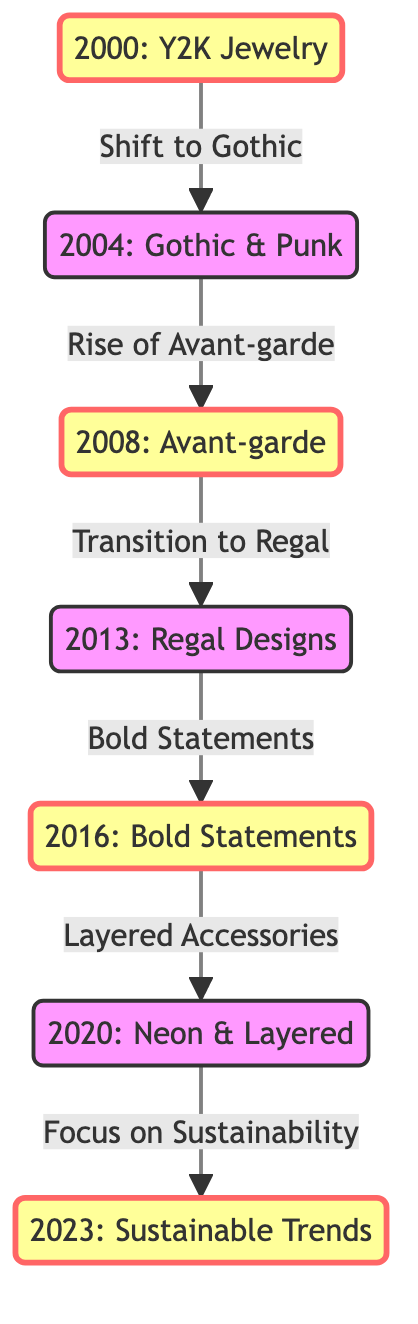What is the first year mentioned in the diagram? The diagram begins with the node labeled "2000: Y2K Jewelry," establishing 2000 as the first year related to jewelry design trends.
Answer: 2000 What type of jewelry trend follows "Y2K Jewelry"? The arrow leading from 2000 to 2004 indicates a connection that identifies the next trend as "Gothic & Punk."
Answer: Gothic & Punk Which year marks the introduction of "Regal Designs"? From the diagram, "Regal Designs" is stated in the node labeled 2013, indicating this was the year it was introduced.
Answer: 2013 How many milestone trends are displayed in the diagram? The diagram highlights six distinct milestones where the nodes "2000," "2008," "2013," "2016," "2020," and "2023" are all designated as milestone trends, totaling six.
Answer: 6 What is the last trend mentioned in the diagram? The final node shown in the diagram is "2023: Sustainable Trends," which signifies it as the last trend discussed.
Answer: Sustainable Trends Which trend is a transition from "Bold Statements"? The diagram reveals that "Bold Statements," denoted in 2016, transitions to "Layered Accessories" in 2020.
Answer: Layered Accessories What does the arrow from "2004: Gothic & Punk" lead to? The arrow from the 2004 node points to the next node labeled "2008: Avant-garde," indicating the direction of evolution in jewelry design trends.
Answer: 2008: Avant-garde What common theme is found in the last two trends (2020 and 2023)? Both "Layered Accessories" and "Focus on Sustainability" emphasize contemporary approaches to jewelry design reflecting current social concerns and styles.
Answer: Sustainability 